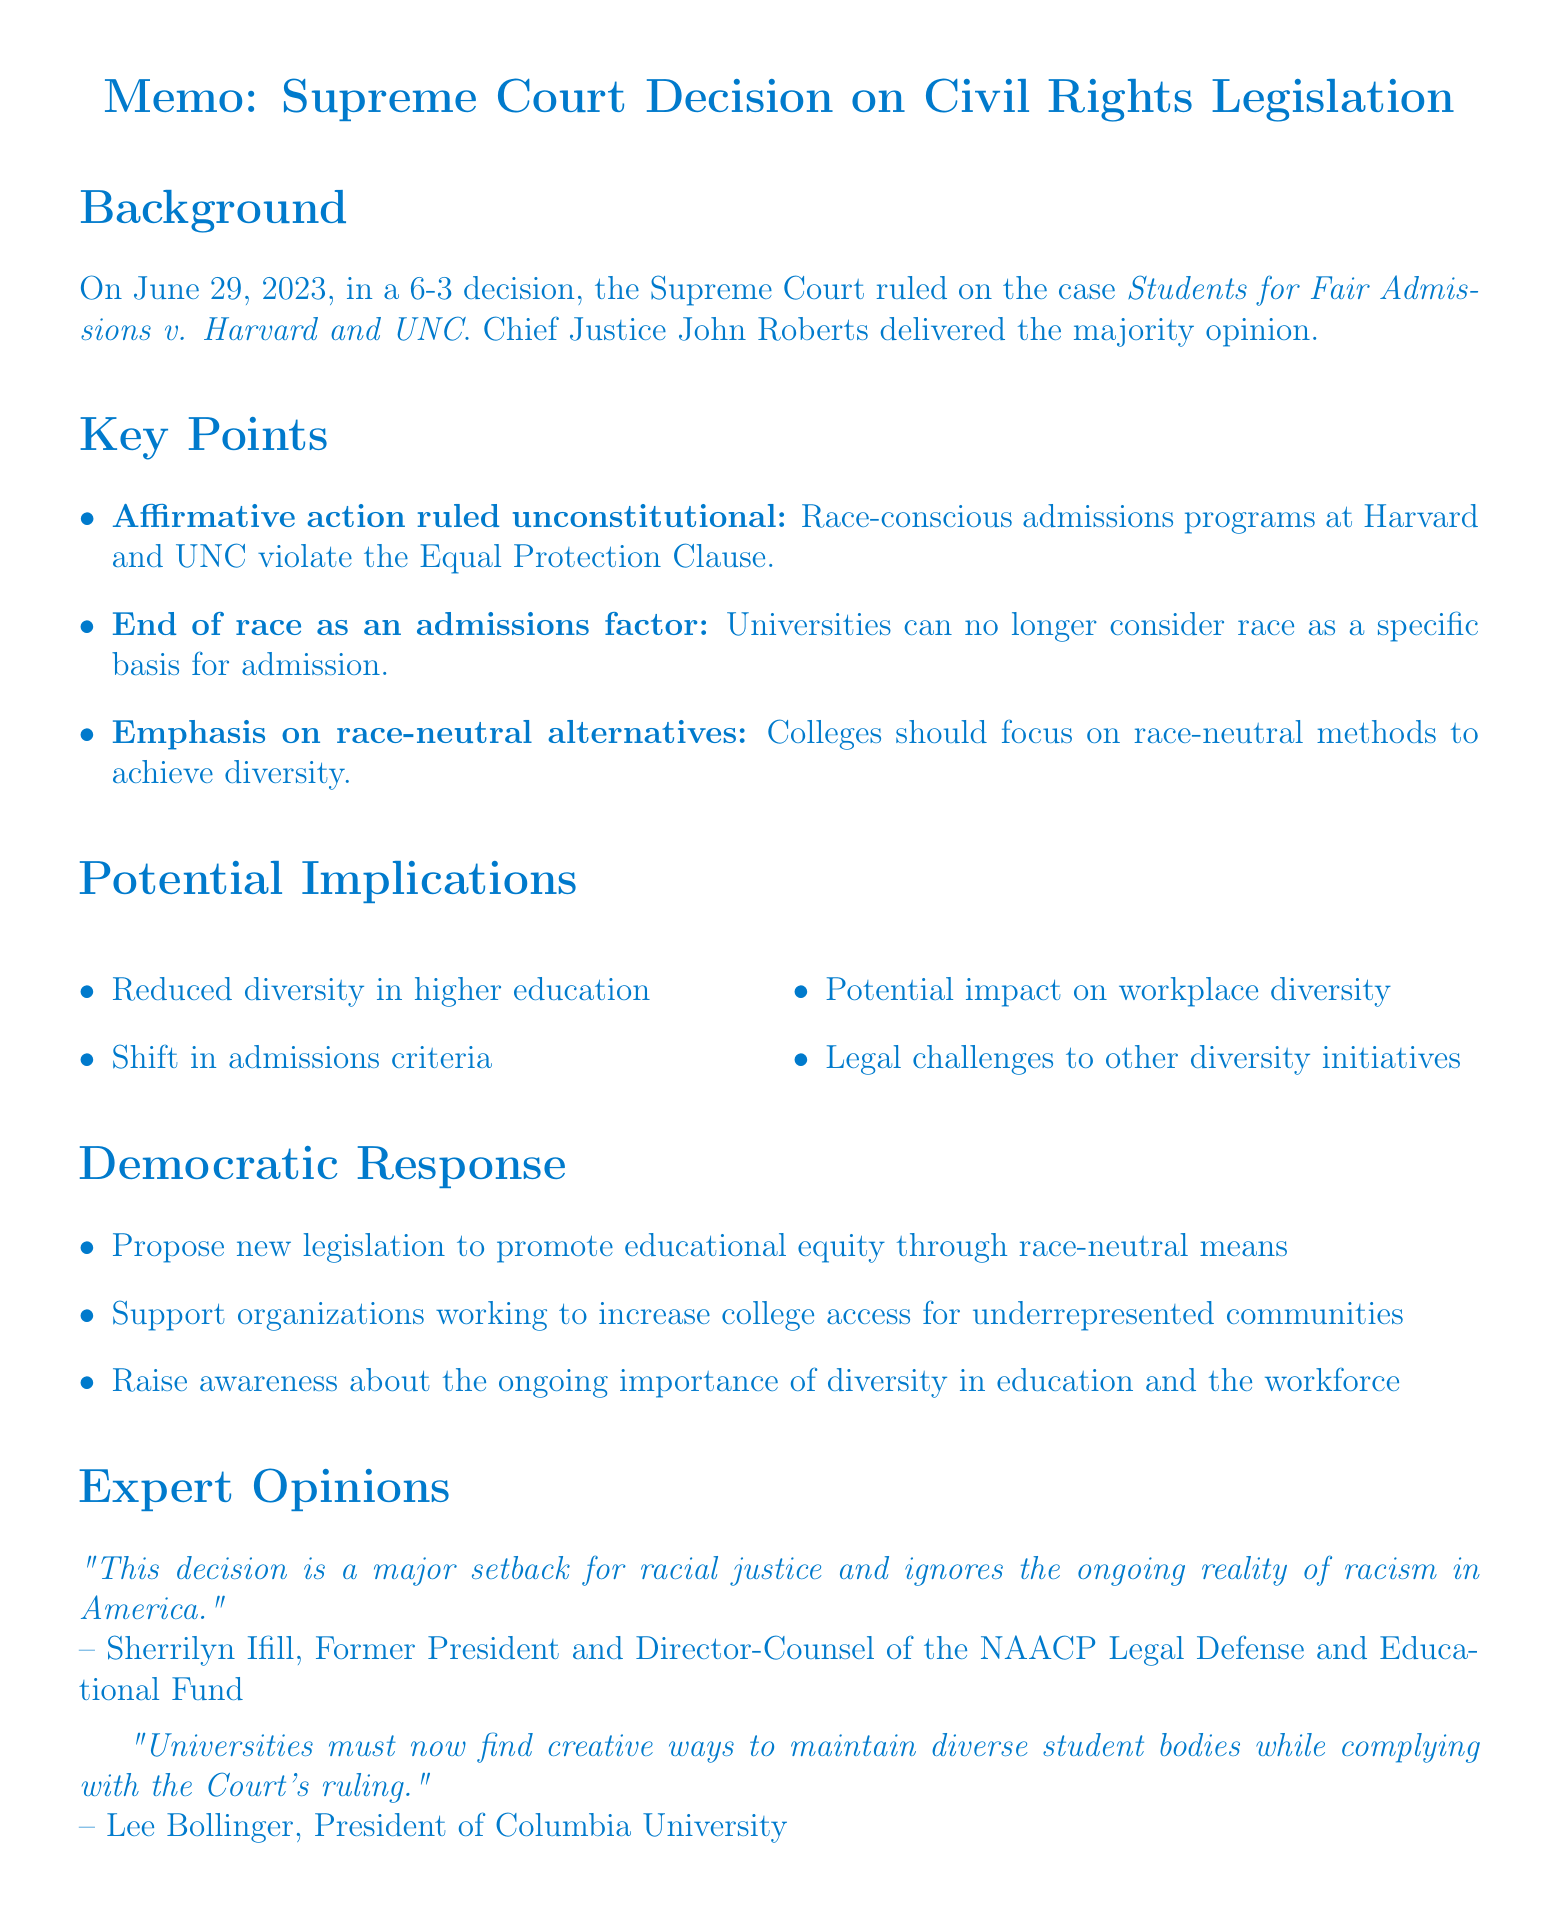What was the decision date of the case? The decision date of the case Students for Fair Admissions v. Harvard and UNC is mentioned in the background section of the memo.
Answer: June 29, 2023 Who delivered the majority opinion? The name of the Chief Justice who delivered the majority opinion is provided in the background section of the document.
Answer: Chief Justice John Roberts What is the main point of the ruling regarding affirmative action? The key points section outlines that the ruling pertains to race-conscious admissions programs violating the Equal Protection Clause.
Answer: Affirmative action in college admissions ruled unconstitutional What are universities no longer allowed to consider in admissions? The document specifically states what factors are excluded in university admissions due to the ruling.
Answer: Race What is one suggested alternative to race-conscious admissions? The key points section suggests that colleges should seek alternative methods for achieving diversity.
Answer: Race-neutral alternatives What are the potential implications of the decision on diversity in higher education? The potential implications section outlines the impacts of the ruling on various aspects of diversity in education.
Answer: Reduced diversity in higher education What is one of the Democratic responses to the ruling? The document details suggested actions that Democrats may take in response to this court decision.
Answer: Propose new legislation to promote educational equity Who expressed concern about the decision's impact on racial justice? Expert opinions section includes views from notable individuals regarding the implications of the ruling.
Answer: Sherrilyn Ifill What does the conclusion emphasize about the Democratic commitment? The conclusion outlines what Democrats are encouraged to remain committed to despite the challenges posed by the decision.
Answer: Values of inclusivity and opportunity for all 